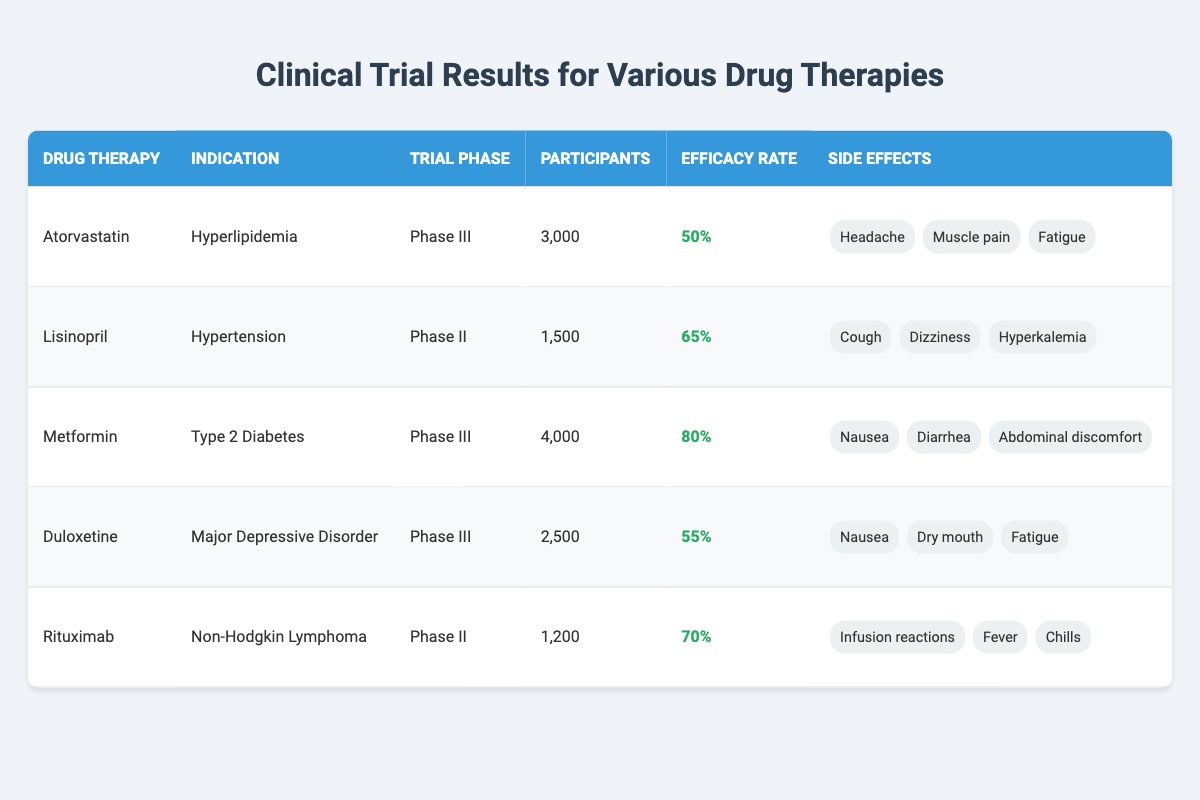What is the efficacy rate of Metformin? The efficacy rate is listed directly in the table under the Metformin entry. It shows a value of 80%.
Answer: 80% How many participants were involved in the clinical trial for Lisinopril? The number of participants is specified in the table next to Lisinopril, which states that there were 1,500 participants.
Answer: 1,500 Which drug therapy has the highest efficacy rate? By inspecting the efficacy rates provided for each drug therapy (50%, 65%, 80%, 55%, 70%), Metformin has the highest efficacy rate of 80%.
Answer: Metformin Is it true that Duloxetine is used for the treatment of Hypertension? Looking at the indication column in the table, Duloxetine is indicated for Major Depressive Disorder, not Hypertension, which is the indication for Lisinopril.
Answer: No What is the total number of participants across all clinical trials listed? Summing the participants from each trial: 3,000 (Atorvastatin) + 1,500 (Lisinopril) + 4,000 (Metformin) + 2,500 (Duloxetine) + 1,200 (Rituximab) = 12,200 participants in total.
Answer: 12,200 How many drugs have side effects that include Nausea? Checking each drug therapy for side effects, both Metformin and Duloxetine list Nausea as a side effect. Therefore, there are 2 drugs that have Nausea among their side effects.
Answer: 2 Which drug has the side effect of Infusion reactions? The side effect of Infusion reactions is specifically mentioned under the Rituximab entry in the side effects column of the table.
Answer: Rituximab What is the average efficacy rate of the drugs in Phase III trials? The efficacy rates for Phase III trials are 50% (Atorvastatin), 80% (Metformin), and 55% (Duloxetine). To find the average, sum them (50 + 80 + 55 = 185) and divide by the number of drugs (185 / 3 = 61.67%).
Answer: 61.67% 